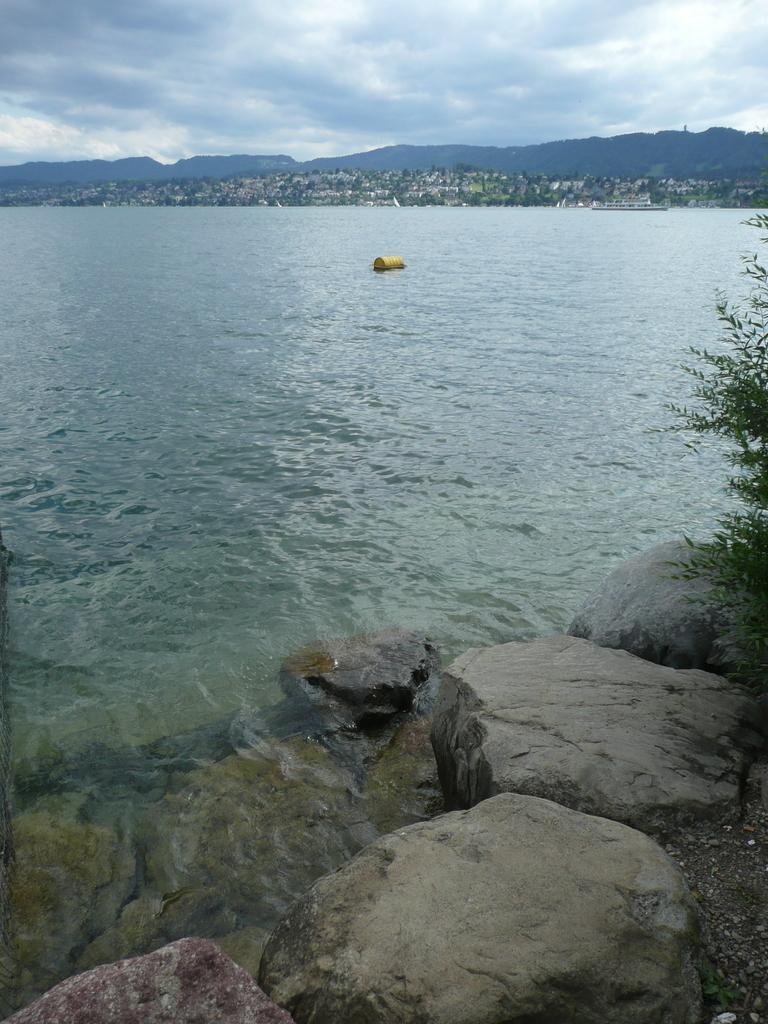What is the primary element visible in the image? There is water in the image. What other objects or features can be seen in the image? There are rocks, a green plant on the right side, mountains, and the sky visible in the image. How is the sky depicted in the image? The sky is visible and cloudy in the image. What news headline is being discussed by the rocks in the image? There are no news headlines or discussions present in the image; it features water, rocks, a green plant, mountains, and a cloudy sky. 